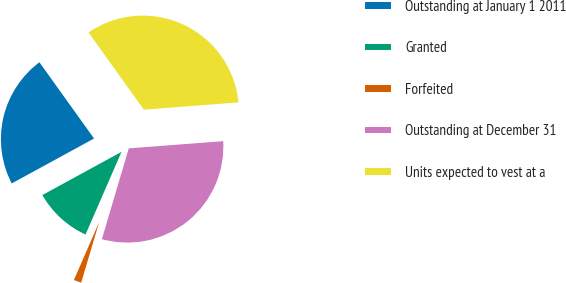<chart> <loc_0><loc_0><loc_500><loc_500><pie_chart><fcel>Outstanding at January 1 2011<fcel>Granted<fcel>Forfeited<fcel>Outstanding at December 31<fcel>Units expected to vest at a<nl><fcel>23.06%<fcel>10.51%<fcel>1.95%<fcel>30.8%<fcel>33.68%<nl></chart> 